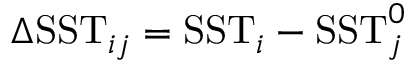Convert formula to latex. <formula><loc_0><loc_0><loc_500><loc_500>\Delta S S T _ { i j } = S S T _ { i } - S S T _ { j } ^ { 0 }</formula> 